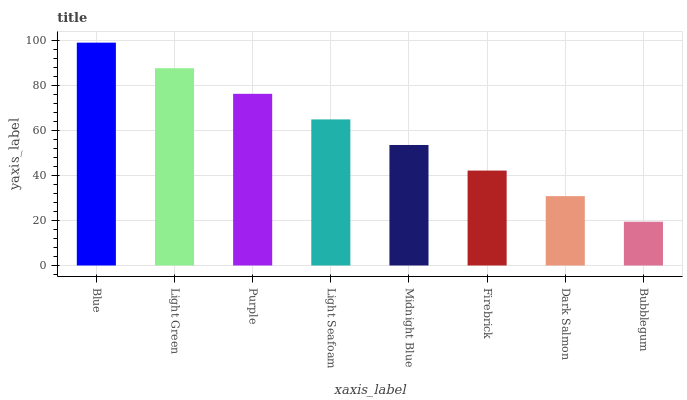Is Bubblegum the minimum?
Answer yes or no. Yes. Is Blue the maximum?
Answer yes or no. Yes. Is Light Green the minimum?
Answer yes or no. No. Is Light Green the maximum?
Answer yes or no. No. Is Blue greater than Light Green?
Answer yes or no. Yes. Is Light Green less than Blue?
Answer yes or no. Yes. Is Light Green greater than Blue?
Answer yes or no. No. Is Blue less than Light Green?
Answer yes or no. No. Is Light Seafoam the high median?
Answer yes or no. Yes. Is Midnight Blue the low median?
Answer yes or no. Yes. Is Blue the high median?
Answer yes or no. No. Is Light Seafoam the low median?
Answer yes or no. No. 